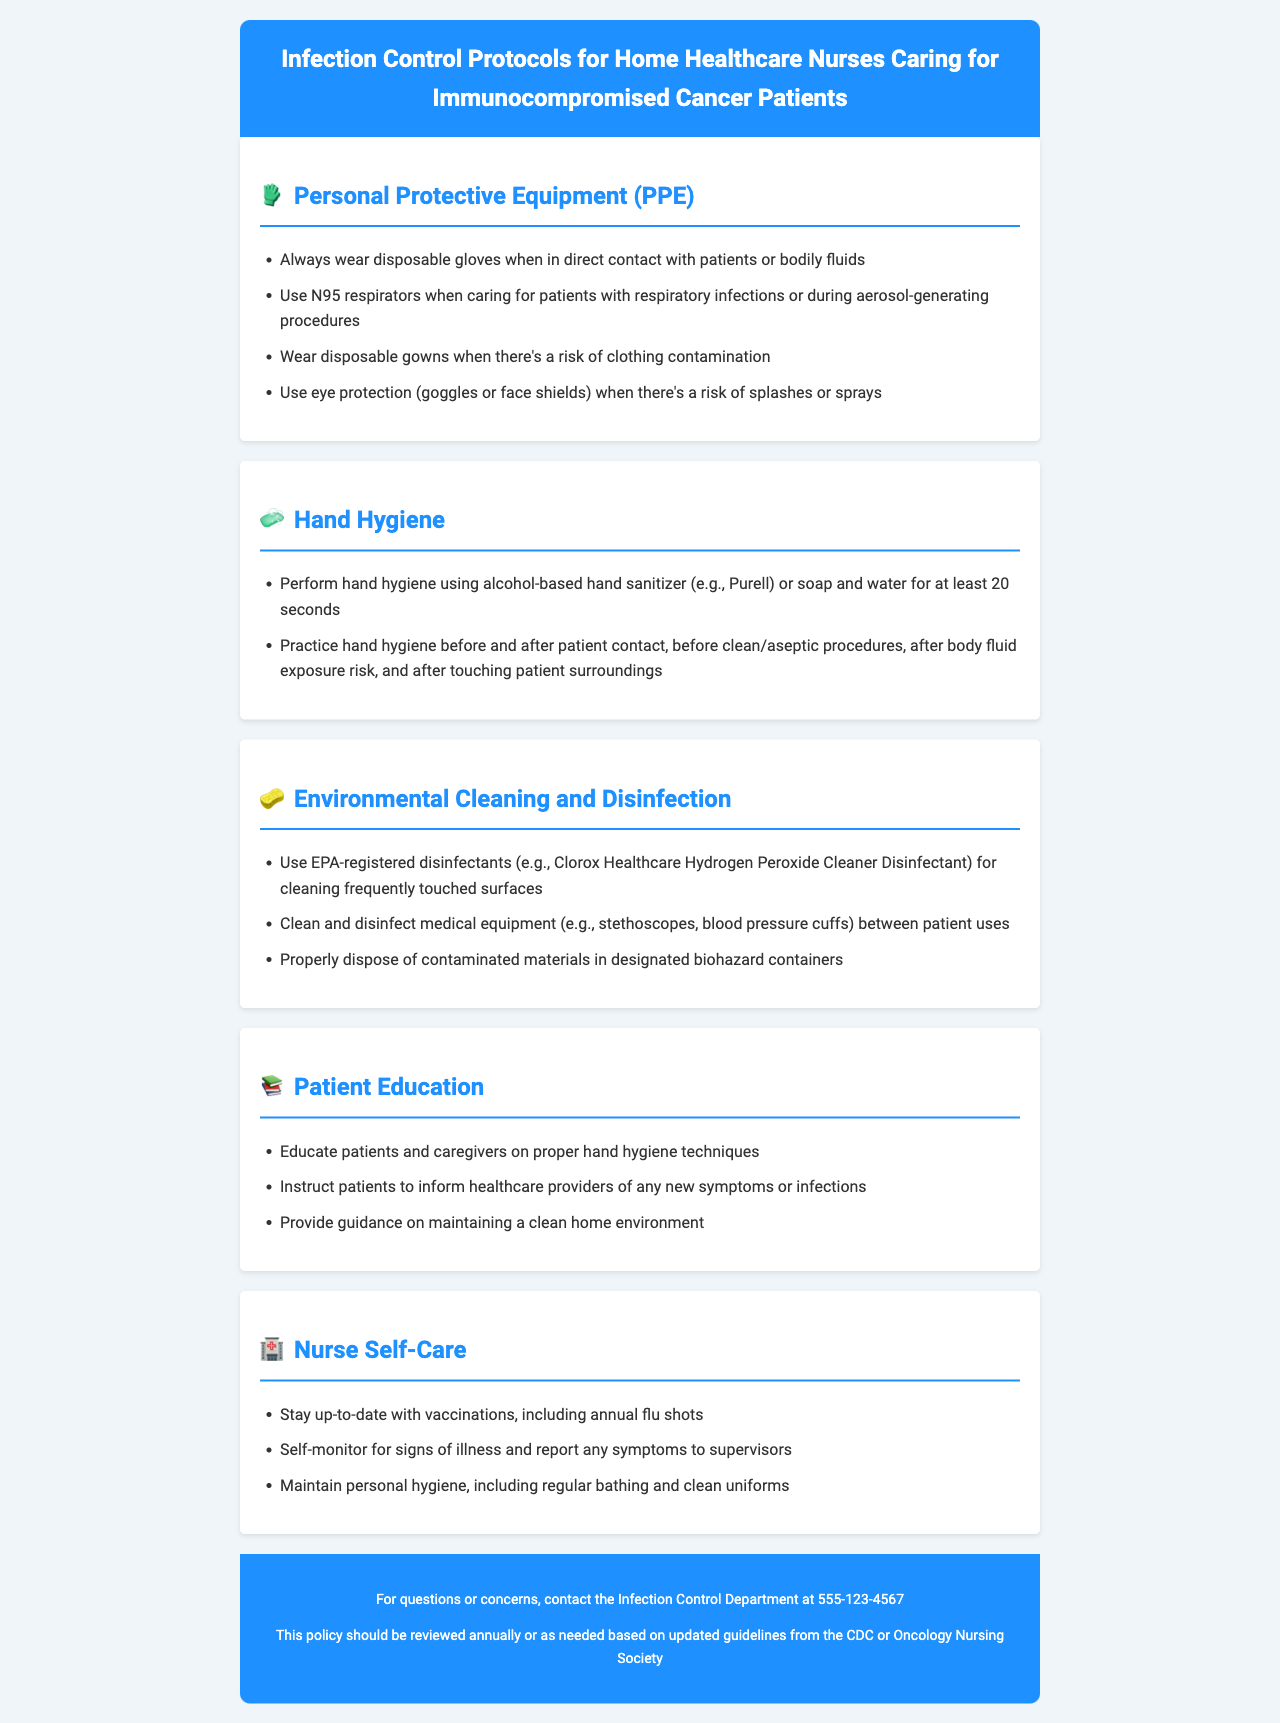What type of respirator should be used during aerosol-generating procedures? The document specifies that N95 respirators should be used when caring for patients with respiratory infections or during aerosol-generating procedures.
Answer: N95 respirators What is the minimum duration for hand hygiene using soap and water? The document states that hand hygiene should be performed for at least 20 seconds using soap and water.
Answer: 20 seconds What should be worn when there is a risk of clothing contamination? The document advises wearing disposable gowns when there is a risk of clothing contamination.
Answer: Disposable gowns Which disinfectant is recommended for cleaning frequently touched surfaces? The document recommends using EPA-registered disinfectants, such as Clorox Healthcare Hydrogen Peroxide Cleaner Disinfectant, for cleaning frequently touched surfaces.
Answer: Clorox Healthcare Hydrogen Peroxide Cleaner Disinfectant What should nurses do to maintain personal hygiene? The document suggests maintaining personal hygiene, including regular bathing and clean uniforms, as part of nurse self-care.
Answer: Regular bathing and clean uniforms Why is patient education important in the infection control protocol? The document highlights educating patients and caregivers on proper hand hygiene techniques and other preventive measures to prevent infections.
Answer: To prevent infections How often should the infection control policy be reviewed? The document states that the policy should be reviewed annually or as needed based on updated guidelines.
Answer: Annually What should be used for hand hygiene in addition to soap and water? The document mentions that alcohol-based hand sanitizer can also be used for hand hygiene.
Answer: Alcohol-based hand sanitizer 